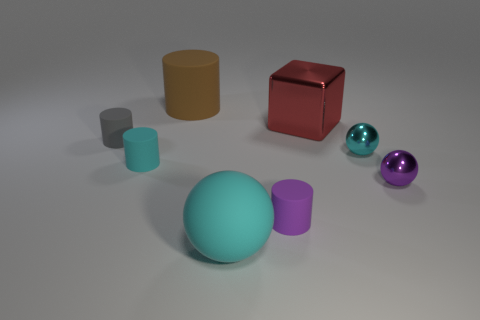Subtract all metal balls. How many balls are left? 1 Add 1 red cylinders. How many objects exist? 9 Subtract all purple balls. How many balls are left? 2 Subtract all spheres. How many objects are left? 5 Subtract 2 spheres. How many spheres are left? 1 Add 8 small purple matte objects. How many small purple matte objects are left? 9 Add 7 cyan metallic spheres. How many cyan metallic spheres exist? 8 Subtract 0 purple cubes. How many objects are left? 8 Subtract all purple cubes. Subtract all yellow cylinders. How many cubes are left? 1 Subtract all yellow cylinders. How many purple balls are left? 1 